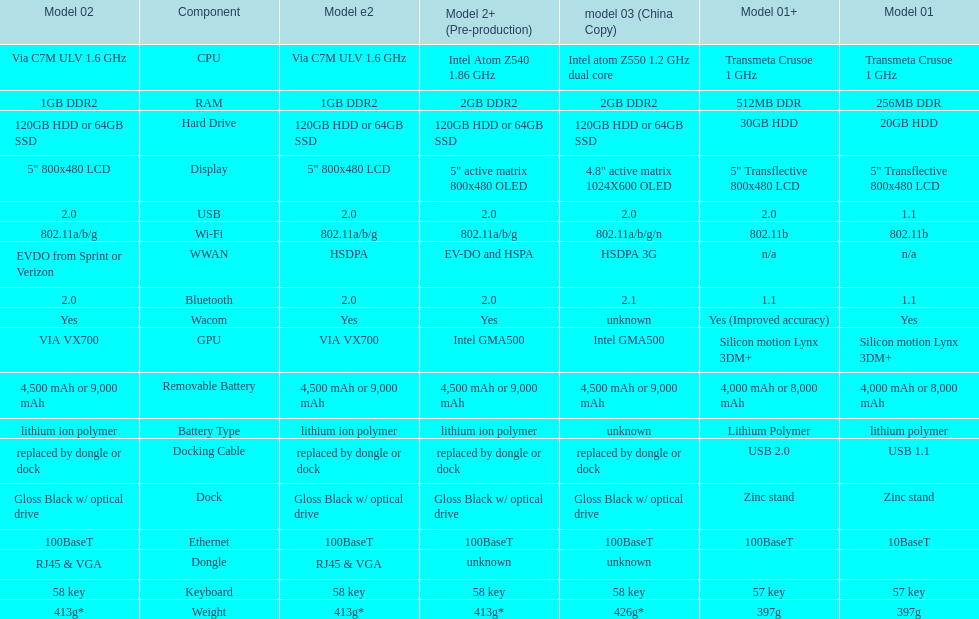Which model provides a larger hard drive: model 01 or model 02? Model 02. 